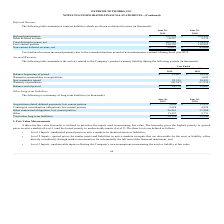From Extreme Networks's financial document, Which years does the table provide information for the company's contract liabilities? The document shows two values: 2019 and 2018. From the document: "2019 2018..." Also, What was the net total deferred revenue in 2019? According to the financial document, 203,242 (in thousands). The relevant text states: "Total deferred revenue, net 203,242 174,525..." Also, What was the other deferred revenue in 2018? According to the financial document, 9,539 (in thousands). The relevant text states: "Other deferred revenue 10,287 9,539..." Also, How many years did Other deferred revenue exceed $10,000 thousand? Based on the analysis, there are 1 instances. The counting process: 2019. Also, can you calculate: What was the change in the amount of Deferred maintenance between 2018 and 2019? Based on the calculation: 192,955-164,986, the result is 27969 (in thousands). This is based on the information: "Deferred maintenance $ 192,955 $ 164,986 Deferred maintenance $ 192,955 $ 164,986..." The key data points involved are: 164,986, 192,955. Also, can you calculate: What was the percentage change in the net Non-current deferred revenue between 2018 and 2019? To answer this question, I need to perform calculations using the financial data. The calculation is: (59,012-43,660)/43,660, which equals 35.16 (percentage). This is based on the information: "Non-current deferred revenue, net $ 59,012 $ 43,660 Non-current deferred revenue, net $ 59,012 $ 43,660..." The key data points involved are: 43,660, 59,012. 